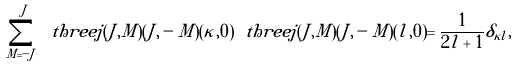Convert formula to latex. <formula><loc_0><loc_0><loc_500><loc_500>\sum _ { M = - J } ^ { J } \ t h r e e j ( J , M ) ( J , - M ) ( \kappa , 0 ) \ t h r e e j ( J , M ) ( J , - M ) ( l , 0 ) = \frac { 1 } { 2 l + 1 } \delta _ { \kappa l } ,</formula> 